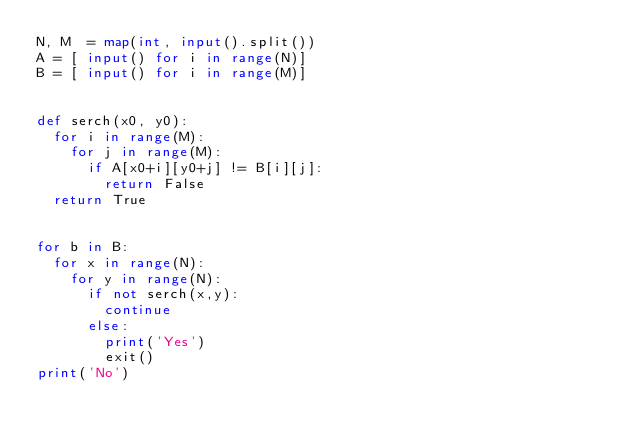<code> <loc_0><loc_0><loc_500><loc_500><_Python_>N, M  = map(int, input().split())
A = [ input() for i in range(N)]
B = [ input() for i in range(M)]


def serch(x0, y0):
  for i in range(M):
    for j in range(M):
      if A[x0+i][y0+j] != B[i][j]:
        return False
  return True


for b in B:
  for x in range(N):
    for y in range(N):
      if not serch(x,y):
        continue
      else:
        print('Yes')
        exit()
print('No')
</code> 